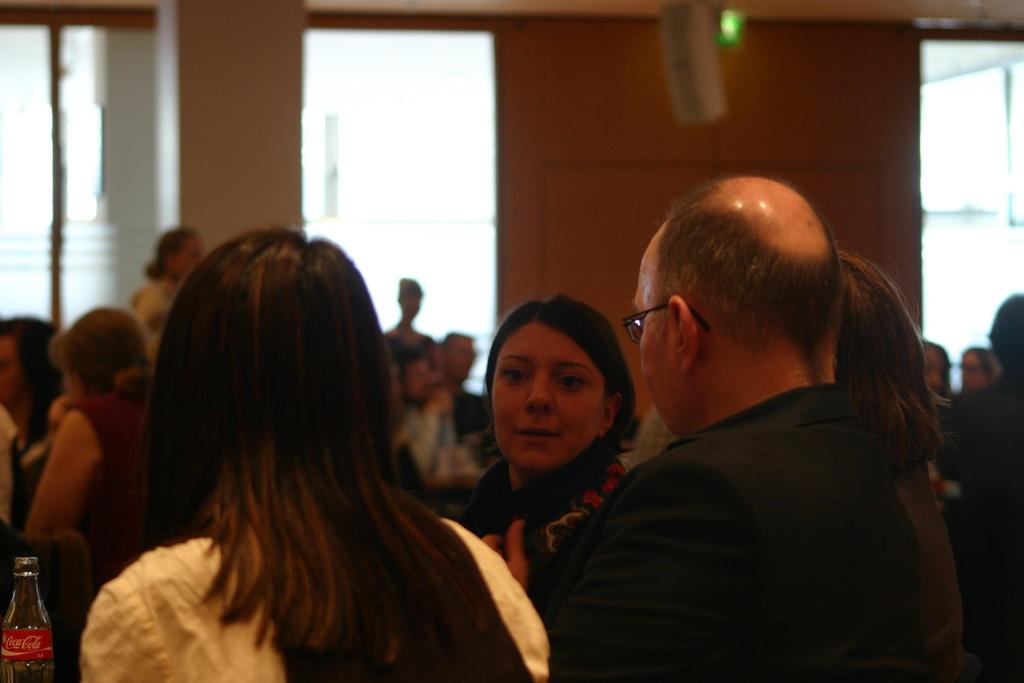What are the people in the image doing? There is a group of persons standing in the image, and there are people sitting on chairs in the image. What can be seen in the background of the image? There is a wall visible in the image. How many giants are present in the image? There are no giants present in the image; it features a group of people standing and sitting. What is the starting point for the people in the image? The image does not indicate a starting point for the people; it simply shows them standing and sitting. 